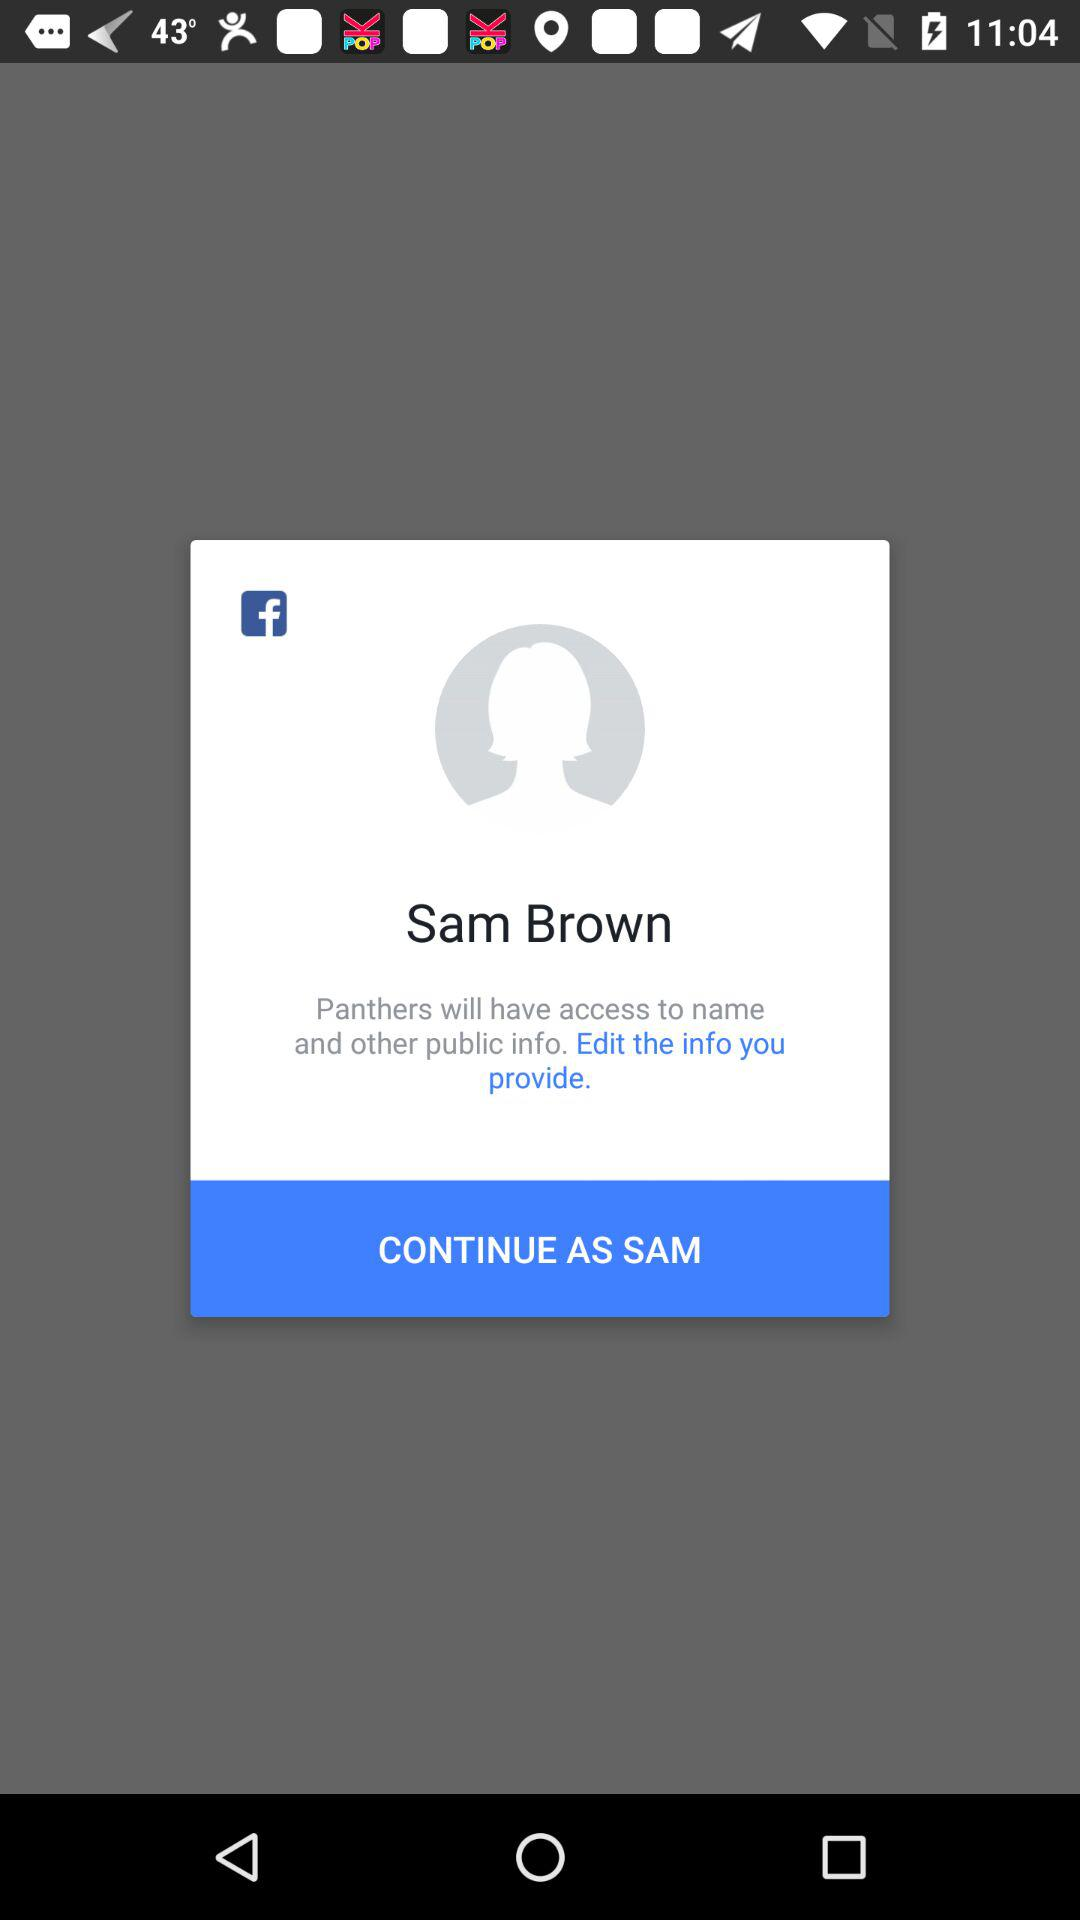What is today's date?
When the provided information is insufficient, respond with <no answer>. <no answer> 